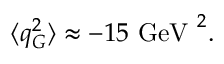<formula> <loc_0><loc_0><loc_500><loc_500>\langle q _ { G } ^ { 2 } \rangle \approx - 1 5 \ G e V \ ^ { 2 } .</formula> 